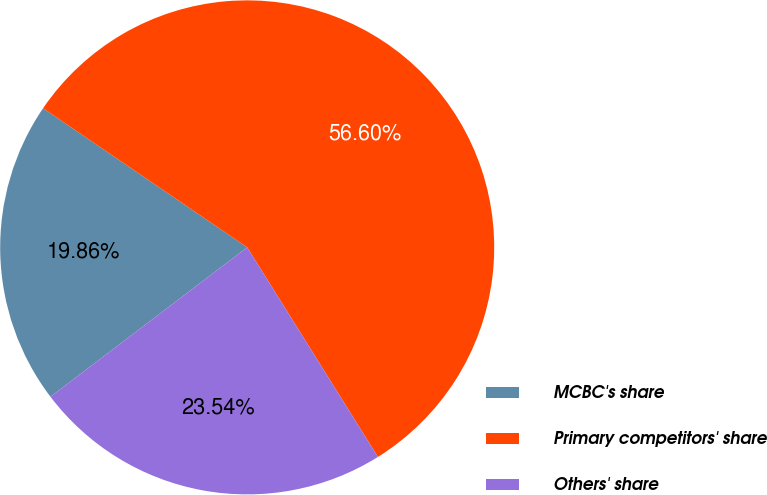Convert chart. <chart><loc_0><loc_0><loc_500><loc_500><pie_chart><fcel>MCBC's share<fcel>Primary competitors' share<fcel>Others' share<nl><fcel>19.86%<fcel>56.6%<fcel>23.54%<nl></chart> 